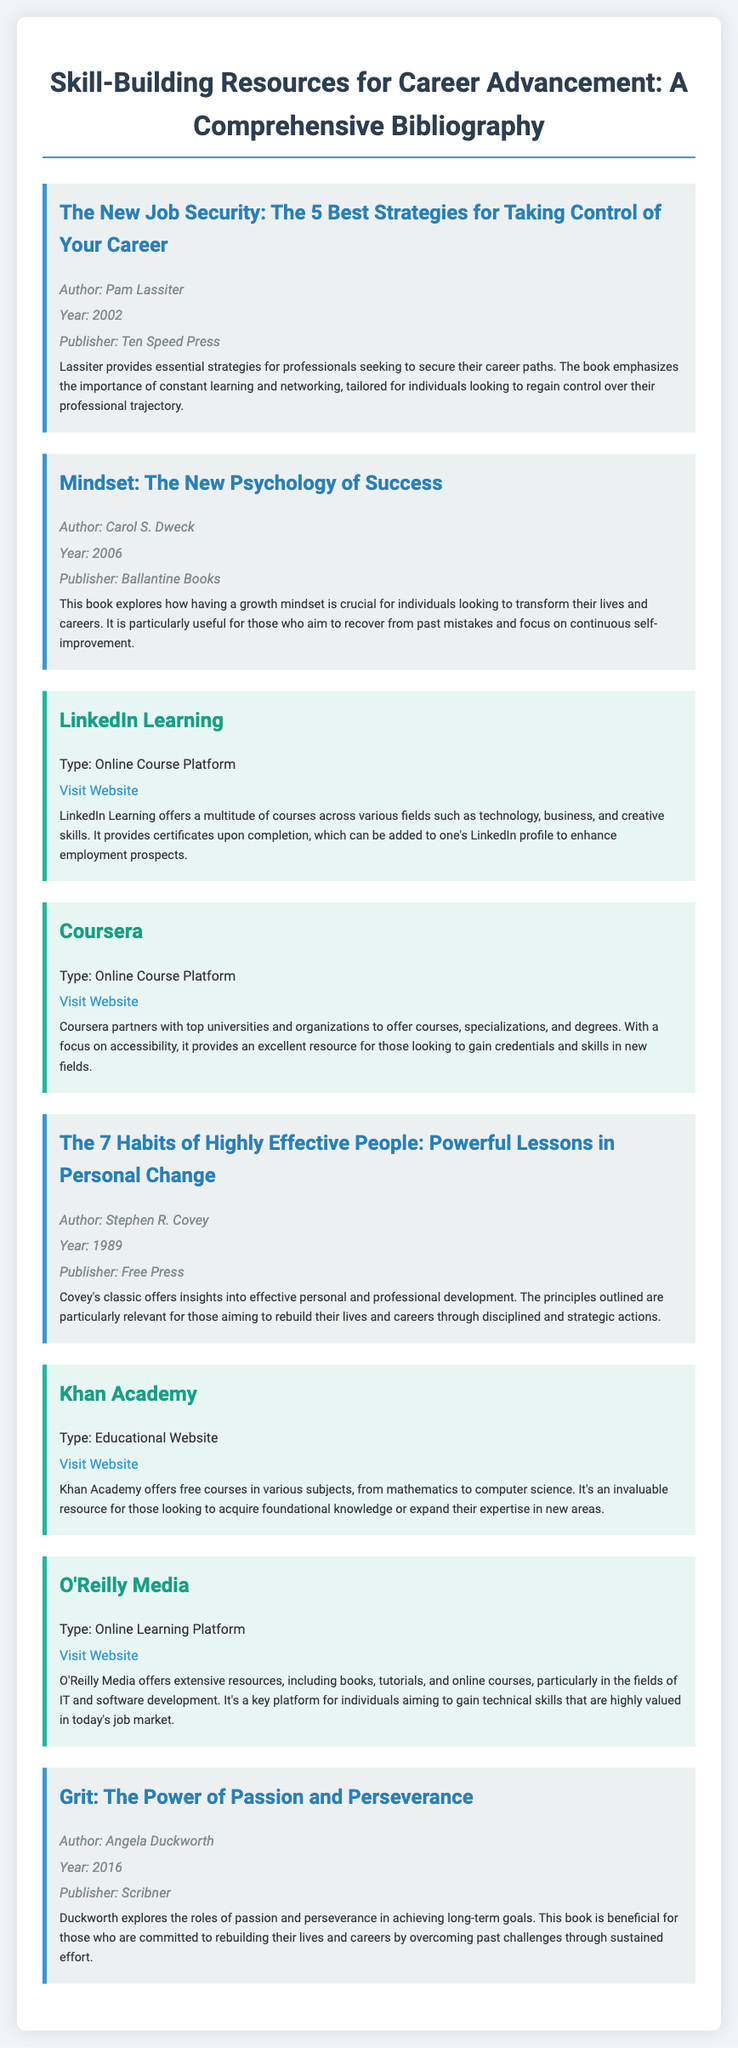What is the title of the first entry? The first entry in the bibliography is titled "The New Job Security: The 5 Best Strategies for Taking Control of Your Career."
Answer: The New Job Security: The 5 Best Strategies for Taking Control of Your Career Who is the author of "Mindset: The New Psychology of Success"? The entry for "Mindset: The New Psychology of Success" lists Carol S. Dweck as the author.
Answer: Carol S. Dweck What year was "The 7 Habits of Highly Effective People" published? The bibliography states that this book was published in 1989.
Answer: 1989 What type of platform is LinkedIn Learning? The entry describes LinkedIn Learning as an Online Course Platform.
Answer: Online Course Platform What is a key theme in Angela Duckworth's book "Grit"? The description highlights the importance of passion and perseverance in achieving long-term goals.
Answer: Passion and perseverance How many online resources are listed in the bibliography? The document contains a total of four entries categorized as online resources.
Answer: Four Which publisher released "The New Job Security"? The bibliography cites Ten Speed Press as the publisher of this book.
Answer: Ten Speed Press What are individuals encouraged to focus on in "Mindset"? The description emphasizes the significance of having a growth mindset for self-improvement.
Answer: Growth mindset What is a benefit of completing courses on Coursera? The entry indicates that Coursera provides excellent resources for gaining credentials and skills in new fields.
Answer: Credentials and skills 